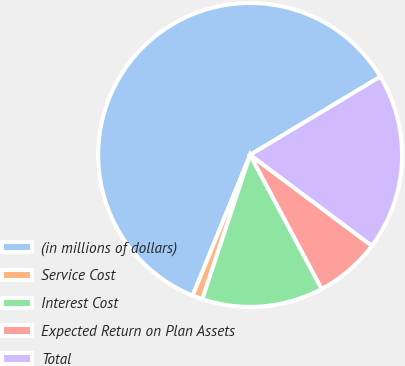Convert chart. <chart><loc_0><loc_0><loc_500><loc_500><pie_chart><fcel>(in millions of dollars)<fcel>Service Cost<fcel>Interest Cost<fcel>Expected Return on Plan Assets<fcel>Total<nl><fcel>60.21%<fcel>1.08%<fcel>12.9%<fcel>6.99%<fcel>18.82%<nl></chart> 